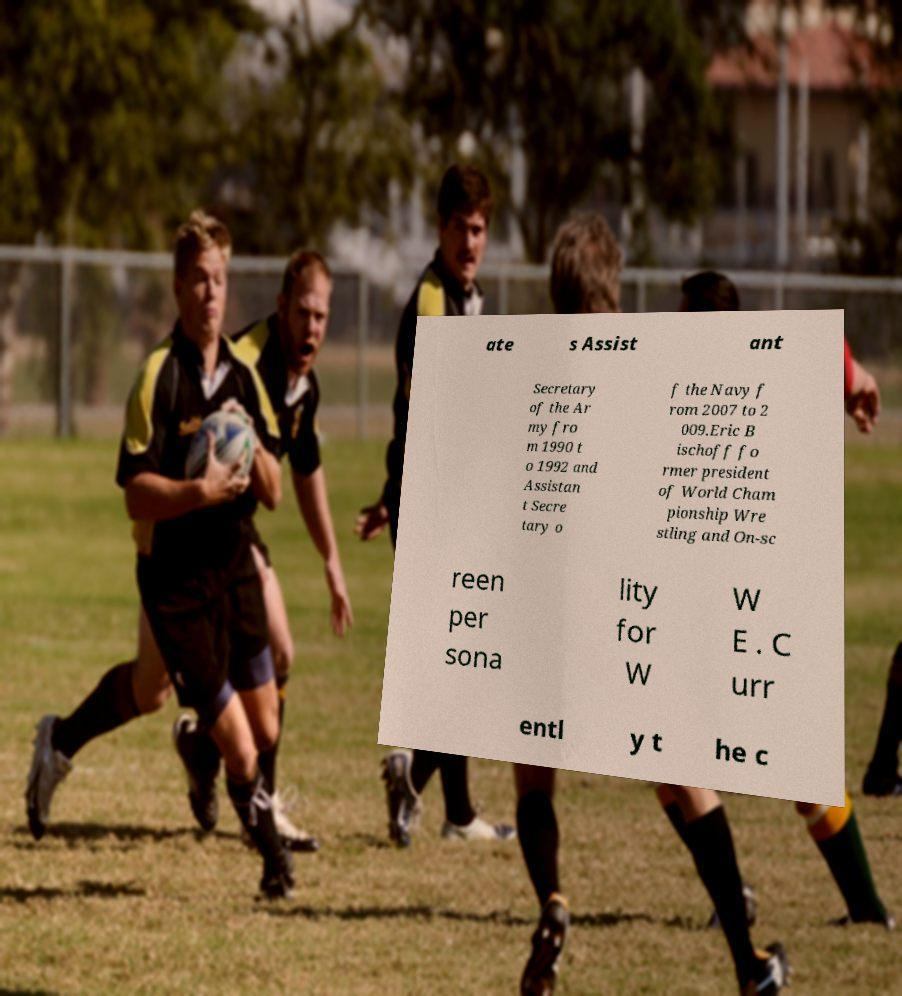Can you accurately transcribe the text from the provided image for me? ate s Assist ant Secretary of the Ar my fro m 1990 t o 1992 and Assistan t Secre tary o f the Navy f rom 2007 to 2 009.Eric B ischoff fo rmer president of World Cham pionship Wre stling and On-sc reen per sona lity for W W E . C urr entl y t he c 